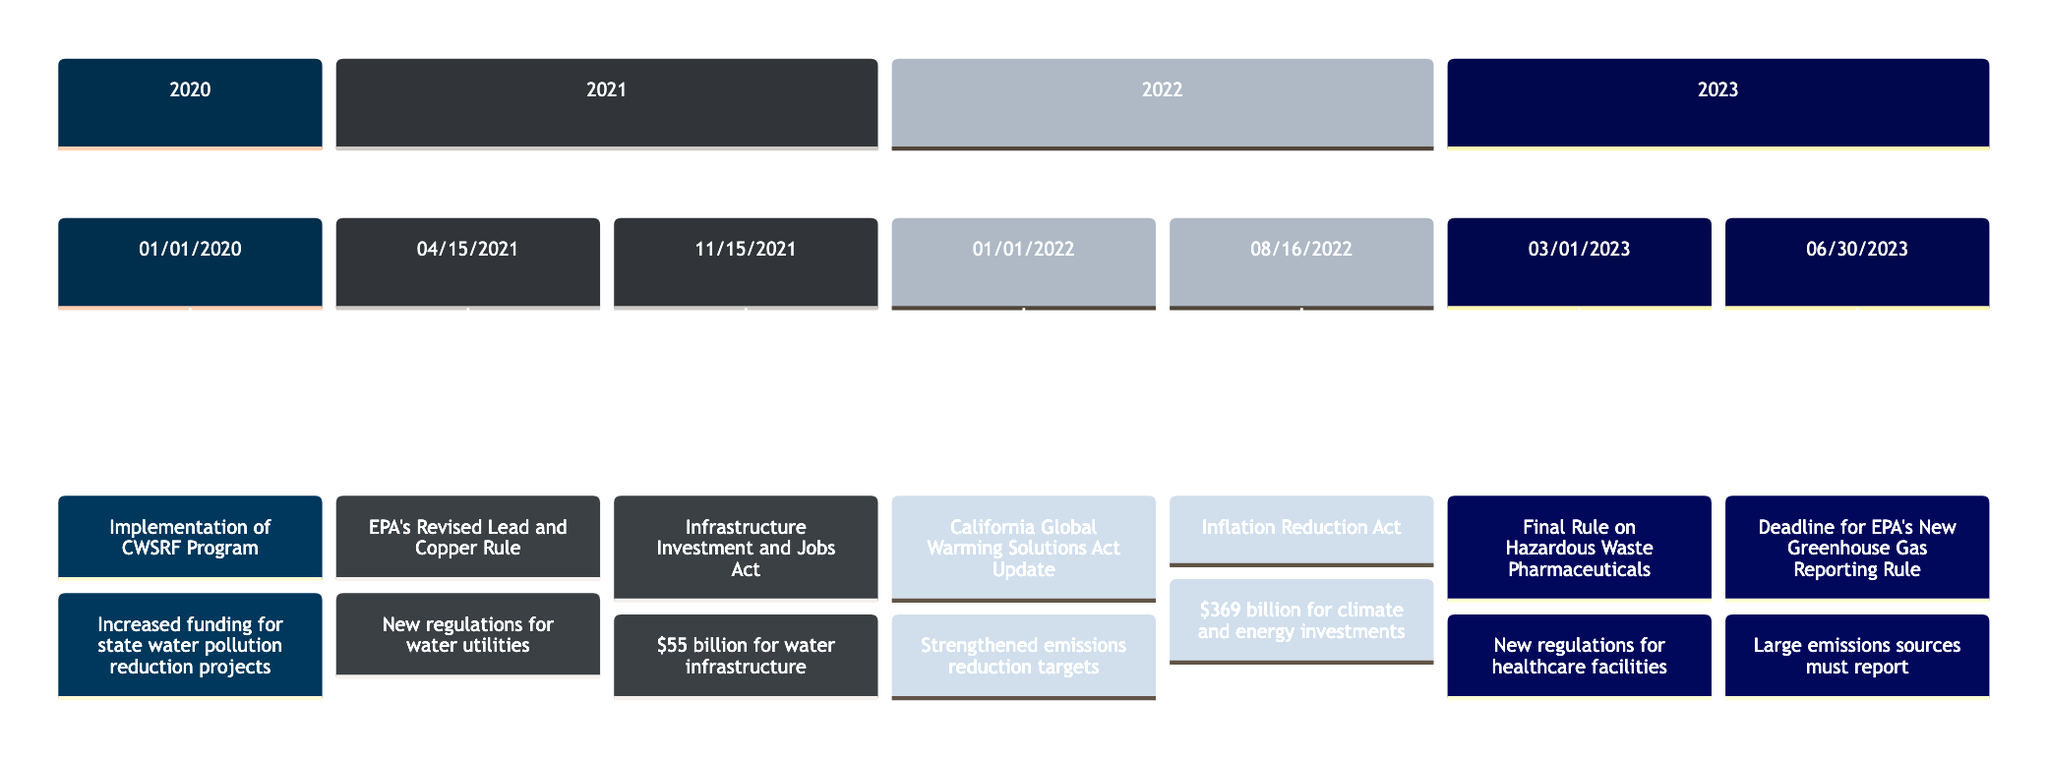What event marks the first regulatory update in 2020? The diagram shows the first event in the year 2020 as "Implementation of the Clean Water State Revolving Fund (CWSRF) Program" which is listed on January 1, 2020.
Answer: Implementation of the Clean Water State Revolving Fund (CWSRF) Program How much funding is provided by the Infrastructure Investment and Jobs Act? According to the diagram, the event on November 15, 2021 mentions "$55 billion for water infrastructure," which highlights the funding amount associated with this act.
Answer: $55 billion What is the deadline for compliance with the EPA’s New Greenhouse Gas Reporting Rule? The diagram indicates that the compliance deadline is noted under the event on June 30, 2023, which specifies the deadline.
Answer: June 30, 2023 Which regulatory update was enacted in 2022 to strengthen emissions reduction targets? The diagram outlines the California Global Warming Solutions Act (AB 32) Update on January 1, 2022, which explicitly mentions the strengthening of emissions reduction targets.
Answer: California Global Warming Solutions Act (AB 32) Update How many events were listed in 2021? Analyzing the timeline for the year 2021, it shows two distinct events: "EPA's Revised Lead and Copper Rule Announcement" on April 15 and "Infrastructure Investment and Jobs Act Enacted" on November 15, indicating a total of two events for that year.
Answer: 2 What is the primary focus of the Biden Administration's Inflation Reduction Act? From the event listed on August 16, 2022 in the diagram, it states that the act includes "$369 billion for climate and energy investments," so the focus of this act is on climate and energy initiatives.
Answer: Climate and energy investments What significant healthcare regulation was finalized in March 2023? The diagram identifies the event on March 1, 2023, as the "Final Rule on the Management of Hazardous Waste Pharmaceuticals," indicating its significance in healthcare regulation.
Answer: Final Rule on the Management of Hazardous Waste Pharmaceuticals What new requirement for water utilities was announced in April 2021? Referring to the event on April 15, 2021, the diagram indicates that the "EPA's Revised Lead and Copper Rule Announcement" mandated new regulations for water utilities, specifying the requirement to replace lead service lines.
Answer: New regulations for water utilities 